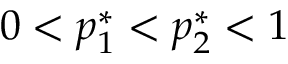Convert formula to latex. <formula><loc_0><loc_0><loc_500><loc_500>0 < p _ { 1 } ^ { * } < p _ { 2 } ^ { * } < 1</formula> 